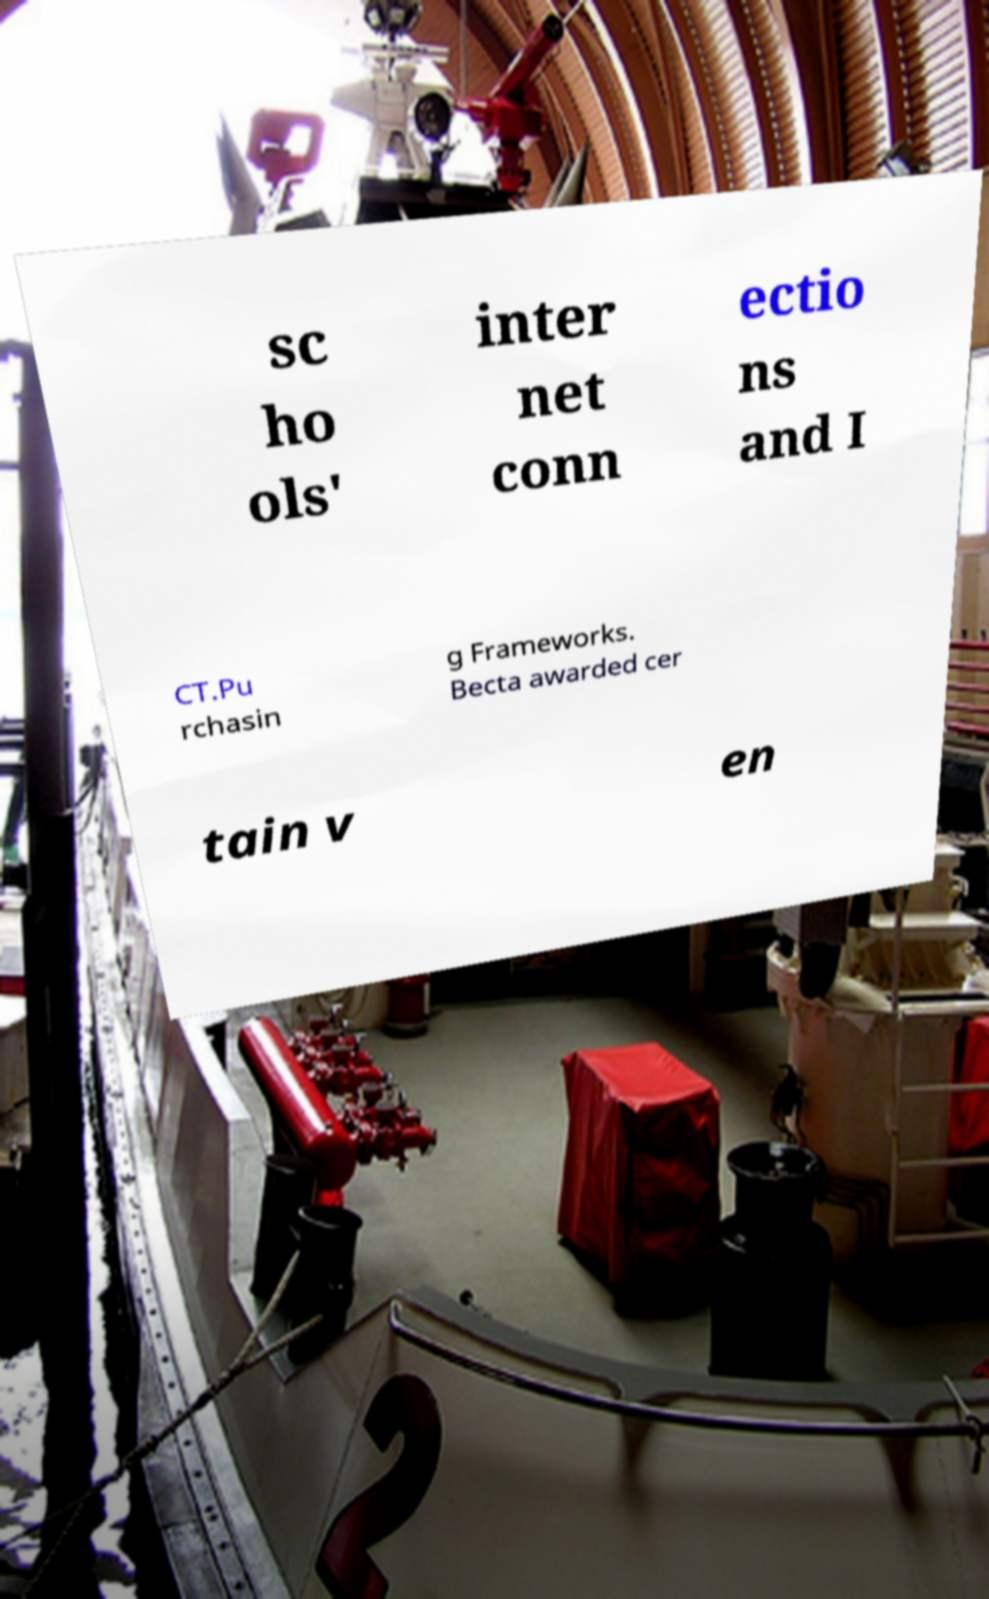I need the written content from this picture converted into text. Can you do that? sc ho ols' inter net conn ectio ns and I CT.Pu rchasin g Frameworks. Becta awarded cer tain v en 